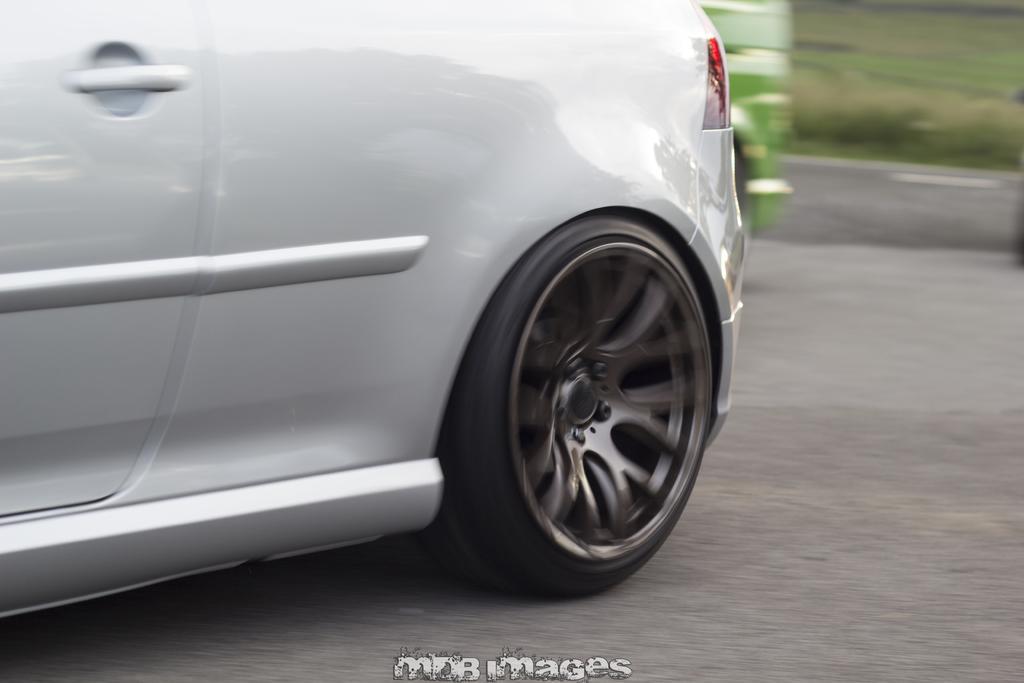Please provide a concise description of this image. In this picture there are vehicles on the road. At the back there is grass. At the bottom there is a text. 